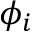Convert formula to latex. <formula><loc_0><loc_0><loc_500><loc_500>\phi _ { i }</formula> 